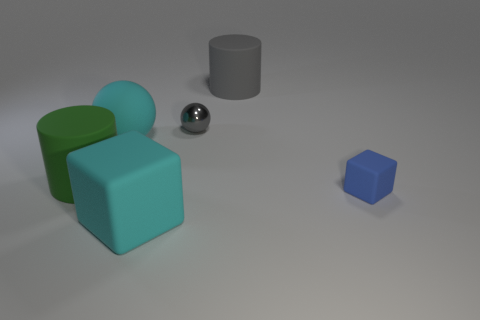Subtract all red balls. Subtract all gray cylinders. How many balls are left? 2 Add 3 yellow shiny blocks. How many objects exist? 9 Subtract all blocks. How many objects are left? 4 Subtract 0 purple cylinders. How many objects are left? 6 Subtract all tiny green spheres. Subtract all tiny shiny spheres. How many objects are left? 5 Add 4 small blue things. How many small blue things are left? 5 Add 3 small yellow cylinders. How many small yellow cylinders exist? 3 